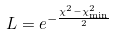Convert formula to latex. <formula><loc_0><loc_0><loc_500><loc_500>L = e ^ { - \frac { \chi ^ { 2 } - \chi ^ { 2 } _ { \min } } { 2 } }</formula> 